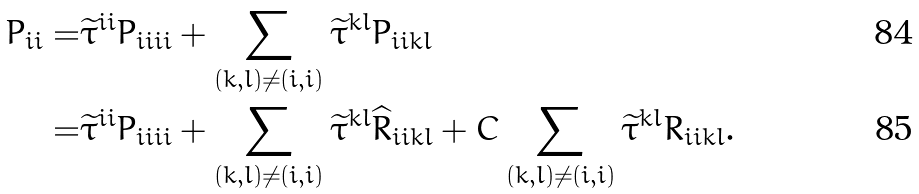Convert formula to latex. <formula><loc_0><loc_0><loc_500><loc_500>P _ { i \bar { i } } = & \widetilde { \tau } ^ { i \bar { i } } P _ { i \bar { i } i \bar { i } } + \sum _ { ( k , l ) \ne ( i , i ) } \widetilde { \tau } ^ { k \bar { l } } P _ { i \bar { i } k \bar { l } } \\ = & \widetilde { \tau } ^ { i \bar { i } } P _ { i \bar { i } i \bar { i } } + \sum _ { ( k , l ) \ne ( i , i ) } \widetilde { \tau } ^ { k \bar { l } } \widehat { R } _ { i \bar { i } k \bar { l } } + C \sum _ { ( k , l ) \ne ( i , i ) } \widetilde { \tau } ^ { k \bar { l } } R _ { i \bar { i } k \bar { l } } .</formula> 